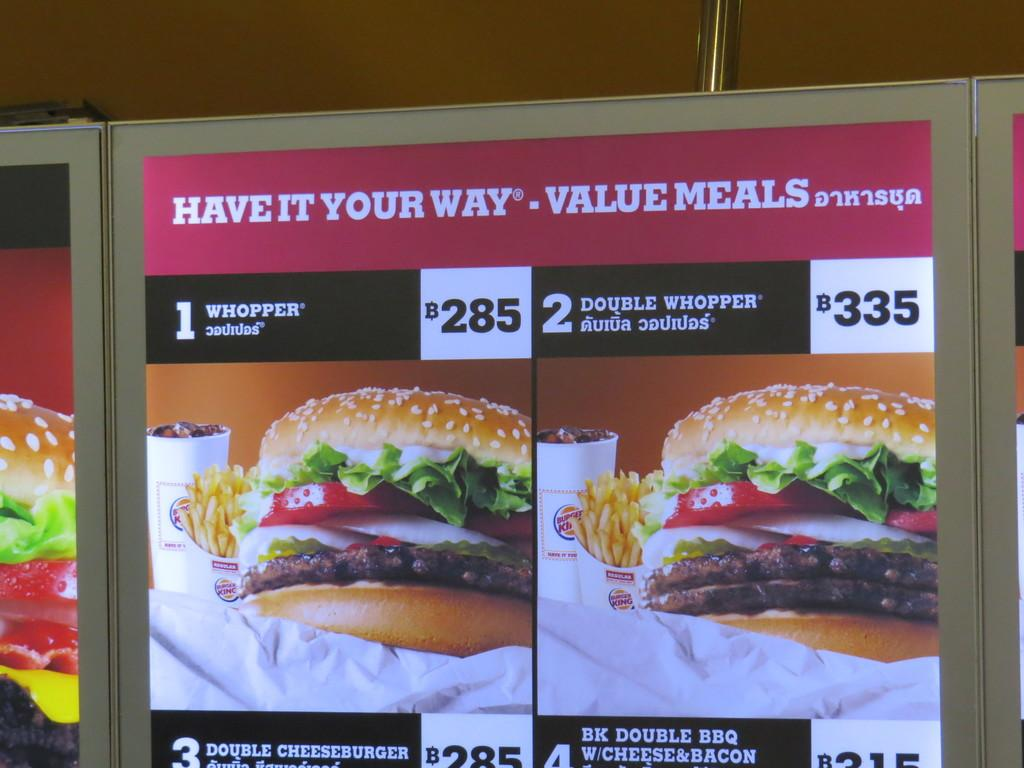What is the main object in the image? There is a board in the image. What is featured on the board? The board contains an advertisement of a burger. What additional information is included in the advertisement? The advertisement includes a price. What grade of can is used to store the burger in the image? There is no can present in the image, and therefore no mention of a specific grade of can. 